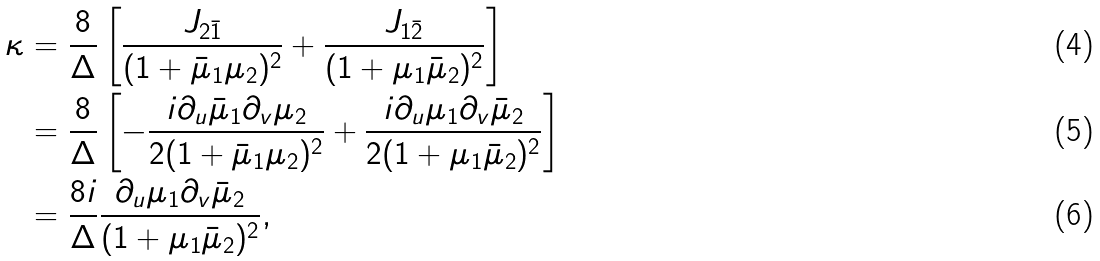Convert formula to latex. <formula><loc_0><loc_0><loc_500><loc_500>\kappa & = \frac { 8 } { \Delta } \left [ \frac { J _ { 2 \bar { 1 } } } { ( 1 + \bar { \mu } _ { 1 } \mu _ { 2 } ) ^ { 2 } } + \frac { J _ { 1 \bar { 2 } } } { ( 1 + \mu _ { 1 } \bar { \mu } _ { 2 } ) ^ { 2 } } \right ] \\ & = \frac { 8 } { \Delta } \left [ - \frac { i \partial _ { u } \bar { \mu } _ { 1 } \partial _ { v } \mu _ { 2 } } { 2 ( 1 + \bar { \mu } _ { 1 } \mu _ { 2 } ) ^ { 2 } } + \frac { i \partial _ { u } \mu _ { 1 } \partial _ { v } \bar { \mu } _ { 2 } } { 2 ( 1 + \mu _ { 1 } \bar { \mu } _ { 2 } ) ^ { 2 } } \right ] \\ & = \frac { 8 i } { \Delta } \frac { \partial _ { u } \mu _ { 1 } \partial _ { v } \bar { \mu } _ { 2 } } { ( 1 + \mu _ { 1 } \bar { \mu } _ { 2 } ) ^ { 2 } } ,</formula> 